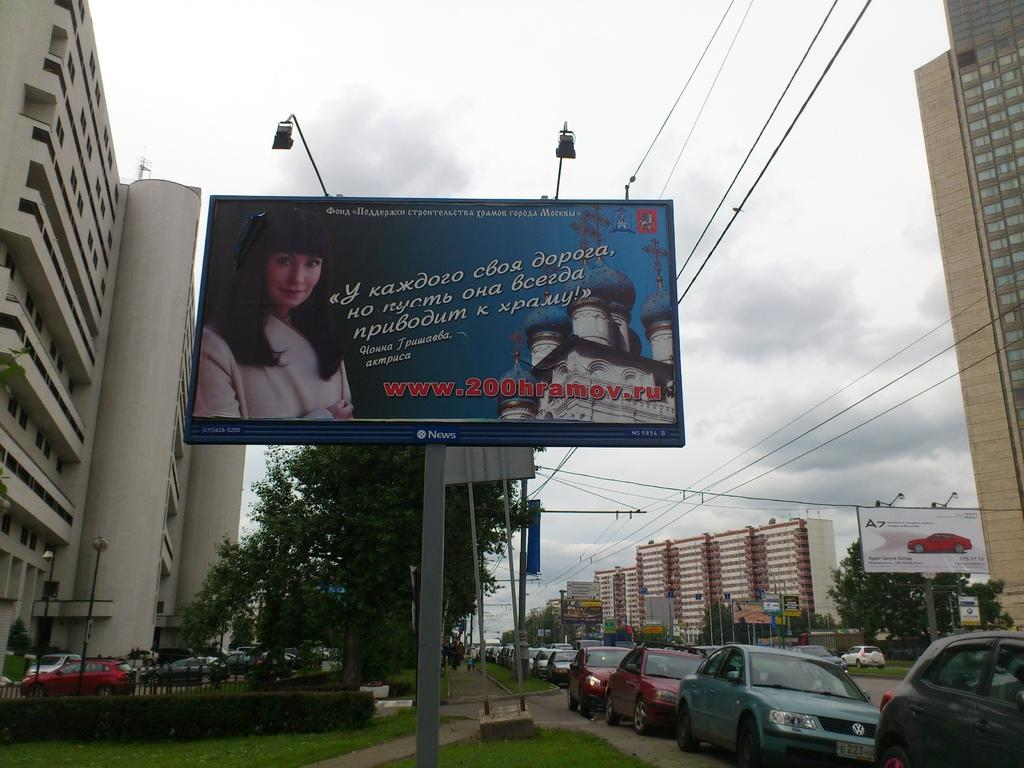What type of signage is present in the image? There are banners in the image. What type of structures can be seen in the image? There are buildings in the image. What type of vegetation is present in the image? There are plants and grass in the image. What type of transportation is present in the image? There are vehicles in the image. What type of traffic control devices are present in the image? There are traffic signals in the image. What is visible at the top of the image? The sky is visible at the top of the image. What type of yarn is being used to decorate the buildings in the image? There is no yarn present in the image; it features banners, buildings, plants, grass, vehicles, traffic signals, and a visible sky. Can you tell me which governor is responsible for the traffic signals in the image? There is no mention of a governor or any political figures in the image, and the traffic signals are not attributed to any specific individual. 